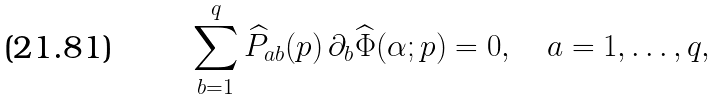Convert formula to latex. <formula><loc_0><loc_0><loc_500><loc_500>\sum _ { b = 1 } ^ { q } \widehat { P } _ { a b } ( p ) \, \partial _ { b } \widehat { \Phi } ( \alpha ; p ) = 0 , \quad a = 1 , \dots , q ,</formula> 